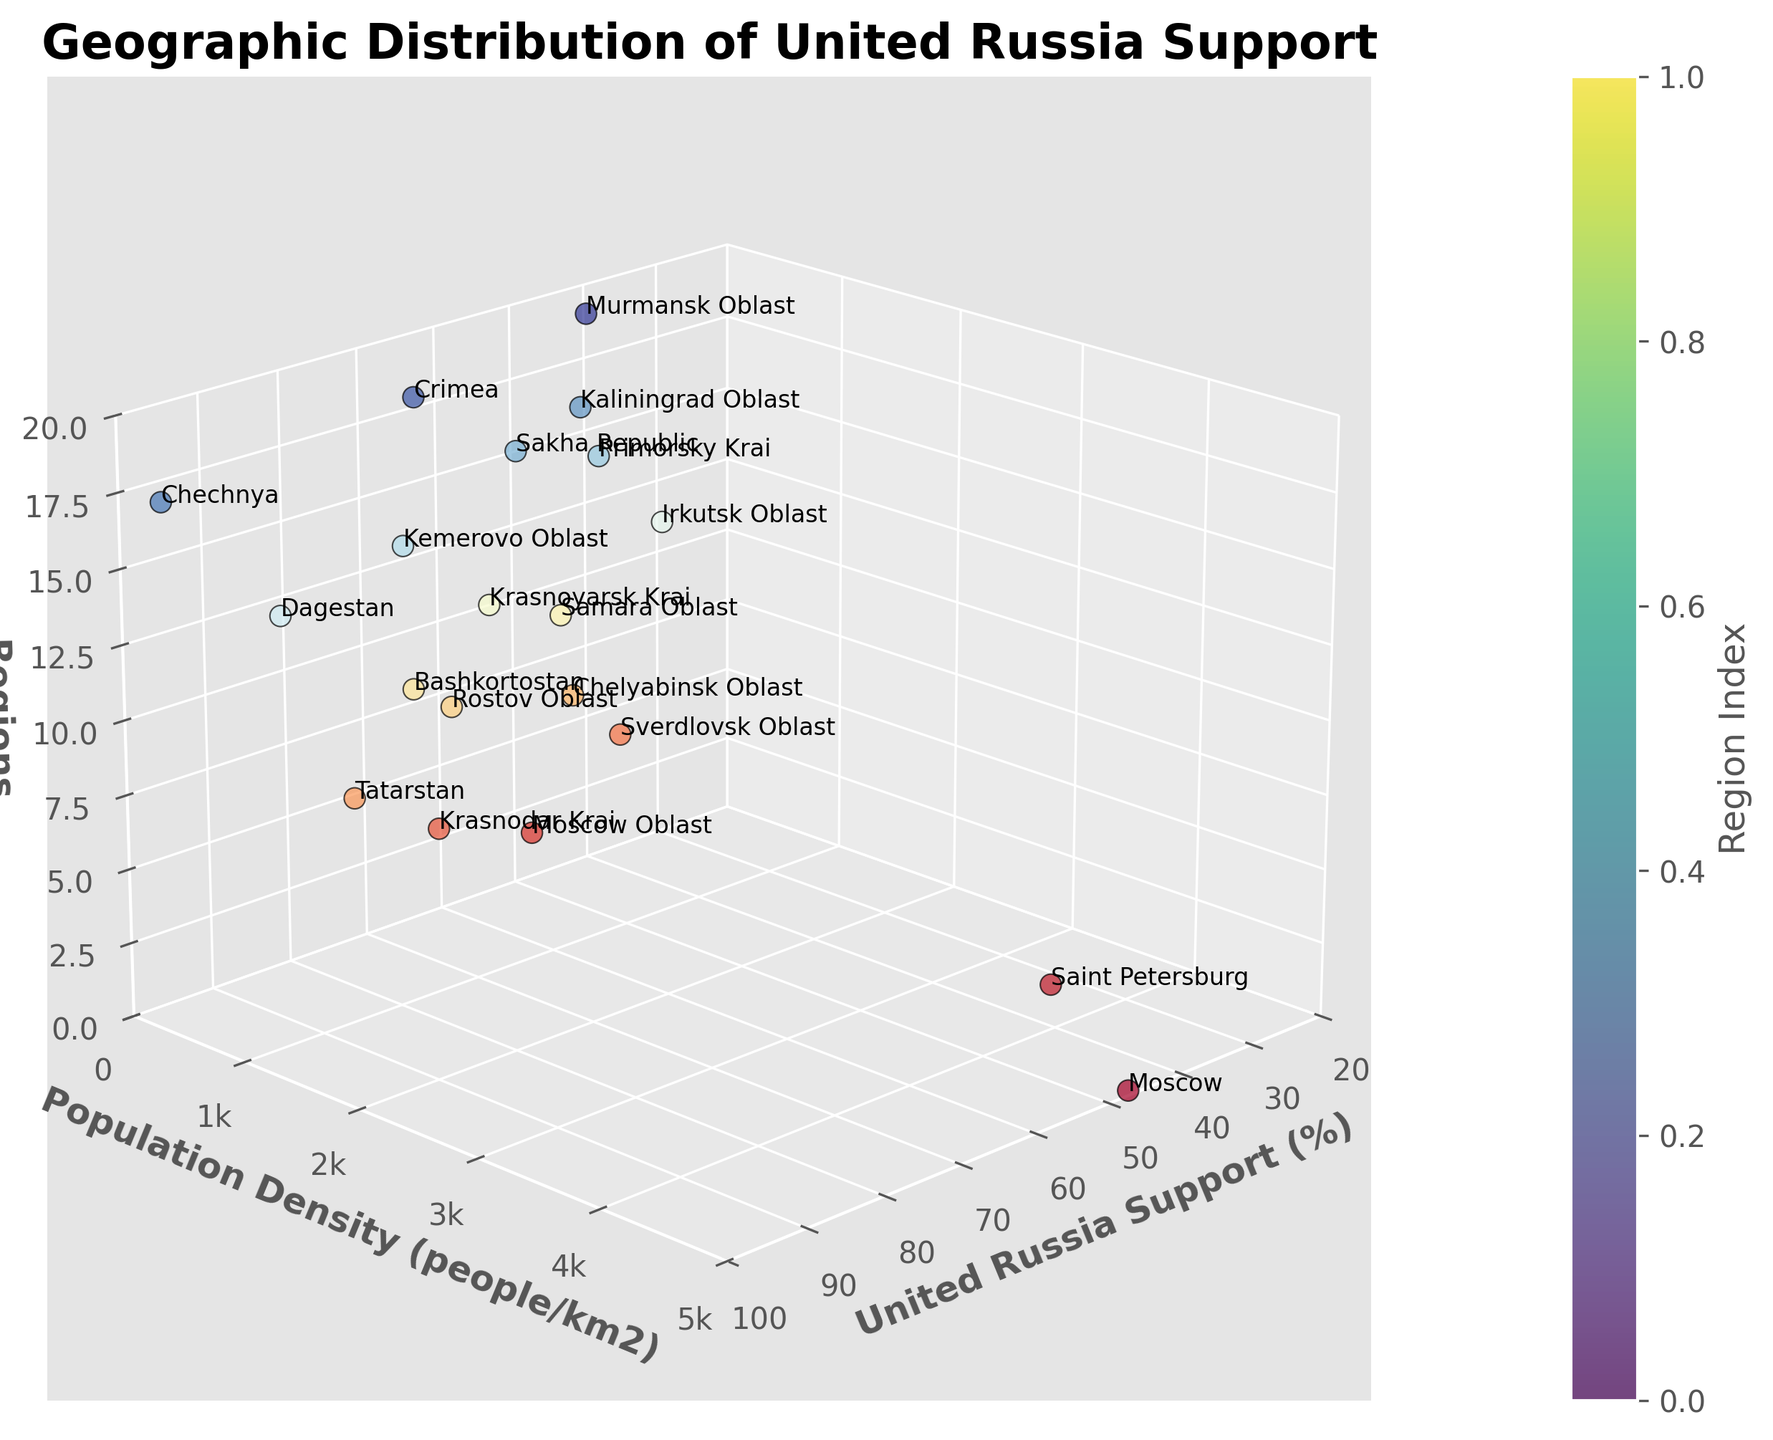What is the title of the figure? The title is prominently displayed at the top of the plot.
Answer: Geographic Distribution of United Russia Support What is the highest population density represented in the plot? Look at the y-axis and find the maximum value of the population density.
Answer: 4950 people/km2 Which region shows the highest support for United Russia and what is its population density? Find the highest value on the x-axis for United Russia Support (%) and note the corresponding region and population density.
Answer: Chechnya, 93.4 people/km2 What is the average population density of the regions with United Russia support above 50%? Identify regions with support above 50%, sum their population densities, and divide by the number of such regions.
Answer: (171 + 74.1 + 57.5 + 62.1 + 39.5 + 41.8 + 28.4 + 73.4 + 27.8) / 9 ≈ 63.6 people/km2 Compare the support for United Russia between Moscow and Saint Petersburg. Which city has higher support? Compare the United Russia Support (%) values of Moscow and Saint Petersburg.
Answer: Moscow, 46.5% Which region has the lowest support for United Russia and what is its population density? Find the lowest value on the x-axis for United Russia Support (%) and note the corresponding region and population density.
Answer: Irkutsk Oblast, 3.1 people/km2 How many regions have a population density lower than 10 people/km2? Count the number of regions with population densities below 10 on the y-axis.
Answer: 4 regions What is the median United Russia Support (%) among the regions? List the support percentages in ascending order and find the middle value.
Answer: 49.3% Between Kaliningrad Oblast and Rostov Oblast, which region has greater support for United Russia? Compare the United Russia Support (%) values of Kaliningrad Oblast and Rostov Oblast.
Answer: Rostov Oblast, 58.9% Which region in the plot has the highest combination of both United Russia support and population density? Consider both x-axis (United Russia Support %) and y-axis (Population Density) to find the region with high values in both.
Answer: Moscow, with 46.5% support and a density of 4950 people/km2 